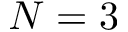Convert formula to latex. <formula><loc_0><loc_0><loc_500><loc_500>N = 3</formula> 